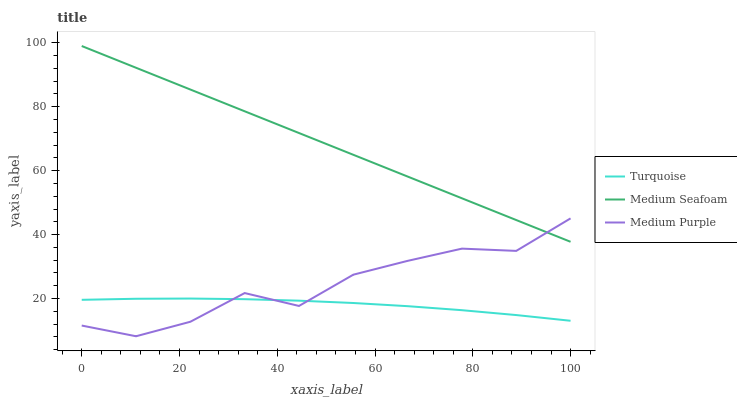Does Medium Seafoam have the minimum area under the curve?
Answer yes or no. No. Does Turquoise have the maximum area under the curve?
Answer yes or no. No. Is Turquoise the smoothest?
Answer yes or no. No. Is Turquoise the roughest?
Answer yes or no. No. Does Turquoise have the lowest value?
Answer yes or no. No. Does Turquoise have the highest value?
Answer yes or no. No. Is Turquoise less than Medium Seafoam?
Answer yes or no. Yes. Is Medium Seafoam greater than Turquoise?
Answer yes or no. Yes. Does Turquoise intersect Medium Seafoam?
Answer yes or no. No. 